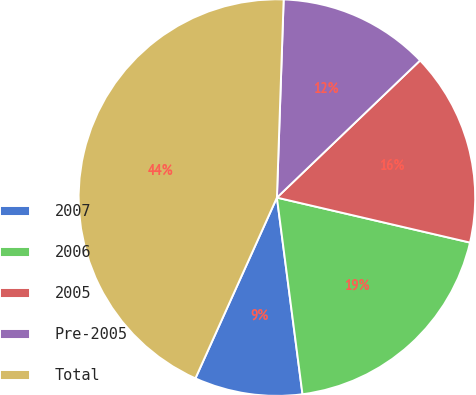Convert chart. <chart><loc_0><loc_0><loc_500><loc_500><pie_chart><fcel>2007<fcel>2006<fcel>2005<fcel>Pre-2005<fcel>Total<nl><fcel>8.8%<fcel>19.3%<fcel>15.8%<fcel>12.3%<fcel>43.8%<nl></chart> 